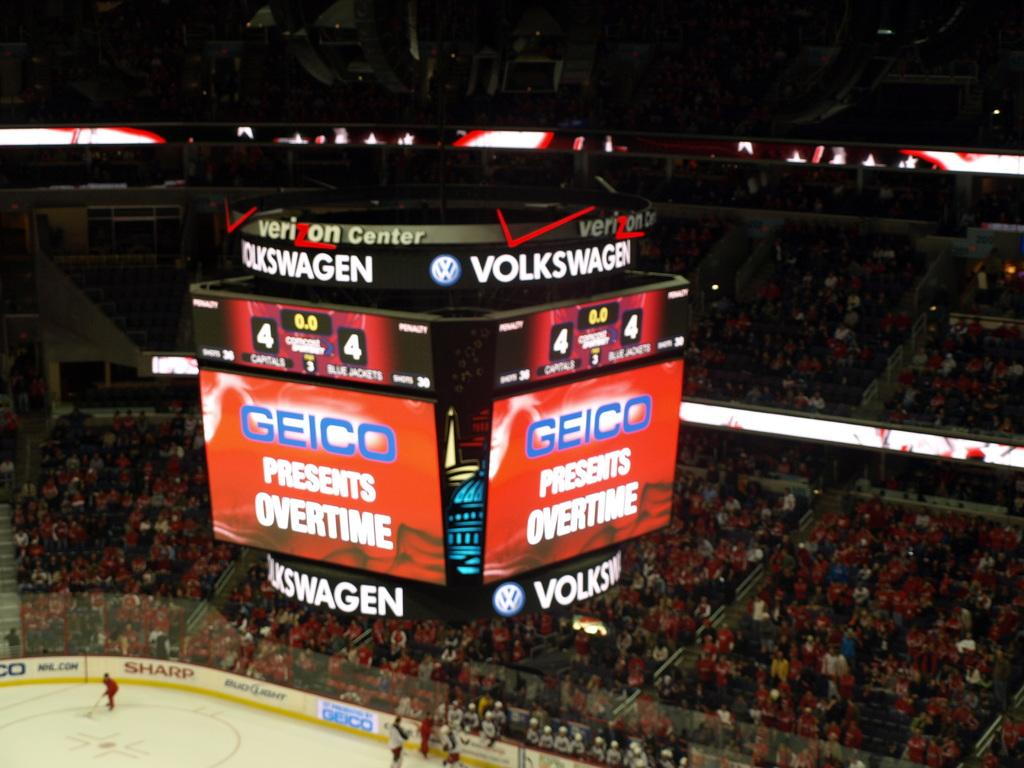<image>
Give a short and clear explanation of the subsequent image. The hockey game is about to go into overtime. 